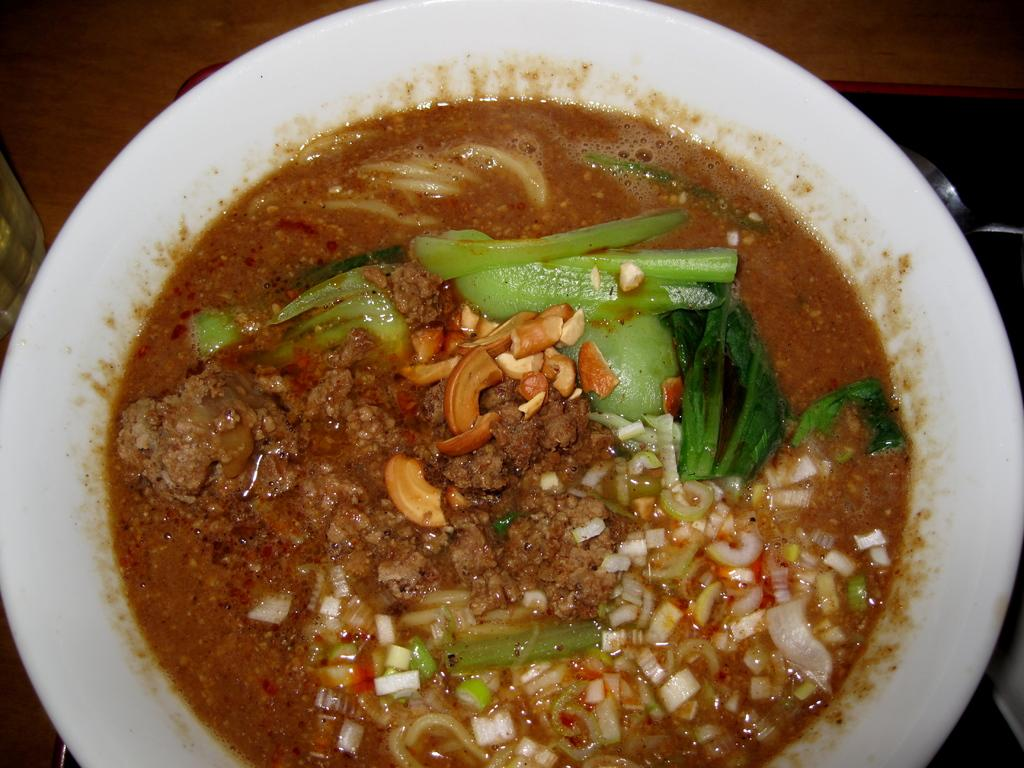What type of objects can be seen in the image? There are food items in the image. Where are the food items placed? The food items are on a white bowl. Can you tell me how many goats are visible in the image? There are no goats present in the image; it features food items on a white bowl. What is the relation between the food items and the drain in the image? There is no drain present in the image, so it is not possible to determine any relation between the food items and a drain. 